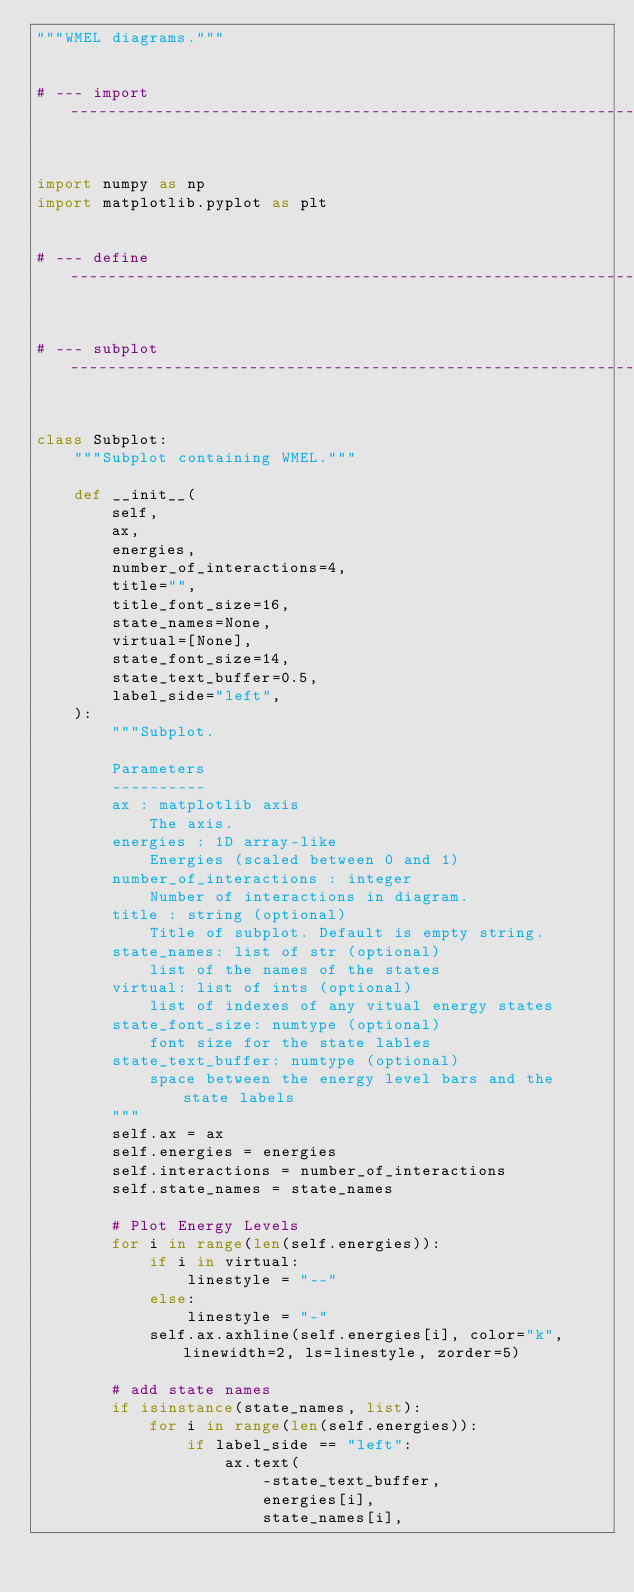Convert code to text. <code><loc_0><loc_0><loc_500><loc_500><_Python_>"""WMEL diagrams."""


# --- import --------------------------------------------------------------------------------------


import numpy as np
import matplotlib.pyplot as plt


# --- define --------------------------------------------------------------------------------------


# --- subplot -------------------------------------------------------------------------------------


class Subplot:
    """Subplot containing WMEL."""

    def __init__(
        self,
        ax,
        energies,
        number_of_interactions=4,
        title="",
        title_font_size=16,
        state_names=None,
        virtual=[None],
        state_font_size=14,
        state_text_buffer=0.5,
        label_side="left",
    ):
        """Subplot.

        Parameters
        ----------
        ax : matplotlib axis
            The axis.
        energies : 1D array-like
            Energies (scaled between 0 and 1)
        number_of_interactions : integer
            Number of interactions in diagram.
        title : string (optional)
            Title of subplot. Default is empty string.
        state_names: list of str (optional)
            list of the names of the states
        virtual: list of ints (optional)
            list of indexes of any vitual energy states
        state_font_size: numtype (optional)
            font size for the state lables
        state_text_buffer: numtype (optional)
            space between the energy level bars and the state labels
        """
        self.ax = ax
        self.energies = energies
        self.interactions = number_of_interactions
        self.state_names = state_names

        # Plot Energy Levels
        for i in range(len(self.energies)):
            if i in virtual:
                linestyle = "--"
            else:
                linestyle = "-"
            self.ax.axhline(self.energies[i], color="k", linewidth=2, ls=linestyle, zorder=5)

        # add state names
        if isinstance(state_names, list):
            for i in range(len(self.energies)):
                if label_side == "left":
                    ax.text(
                        -state_text_buffer,
                        energies[i],
                        state_names[i],</code> 